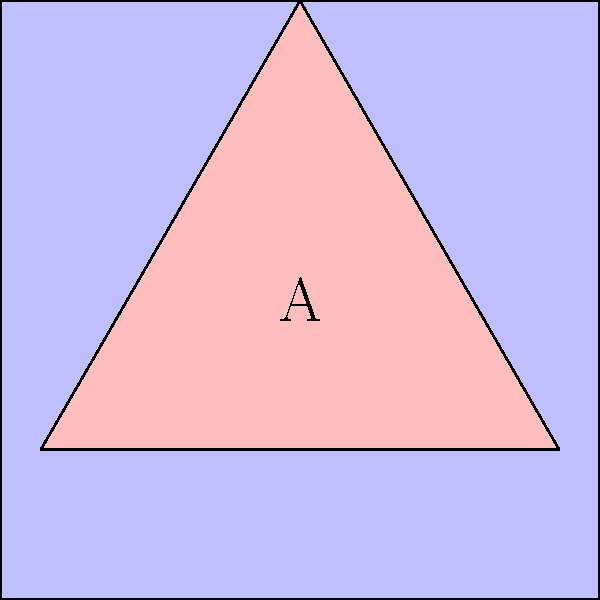In the abstract composition shown, a red triangle is superimposed on a blue square. Considering rotational symmetry, what is the order of the symmetry group for this composition? To determine the order of the symmetry group for this composition, we need to analyze the rotational symmetries:

1. The square has 4-fold rotational symmetry (90°, 180°, 270°, 360°).
2. The equilateral triangle has 3-fold rotational symmetry (120°, 240°, 360°).
3. When combined, we need to find the rotations that leave both shapes invariant.

The only rotation that preserves both shapes simultaneously is the 360° rotation (identity).

Therefore, the composition has only one symmetry operation: the identity.

In group theory, the order of a group is the number of elements in the group. Since there is only one symmetry operation (the identity), the order of the symmetry group for this composition is 1.

This type of group is known as the trivial group or identity group, denoted as $C_1$ or $\{e\}$ in cyclic group notation.
Answer: 1 